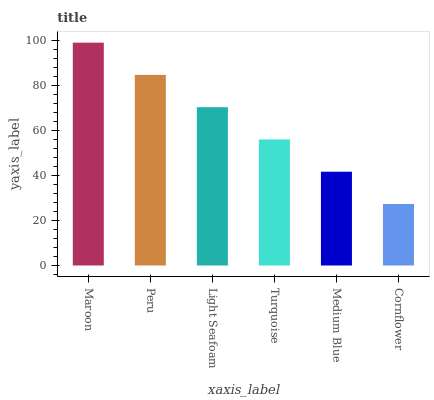Is Cornflower the minimum?
Answer yes or no. Yes. Is Maroon the maximum?
Answer yes or no. Yes. Is Peru the minimum?
Answer yes or no. No. Is Peru the maximum?
Answer yes or no. No. Is Maroon greater than Peru?
Answer yes or no. Yes. Is Peru less than Maroon?
Answer yes or no. Yes. Is Peru greater than Maroon?
Answer yes or no. No. Is Maroon less than Peru?
Answer yes or no. No. Is Light Seafoam the high median?
Answer yes or no. Yes. Is Turquoise the low median?
Answer yes or no. Yes. Is Turquoise the high median?
Answer yes or no. No. Is Medium Blue the low median?
Answer yes or no. No. 